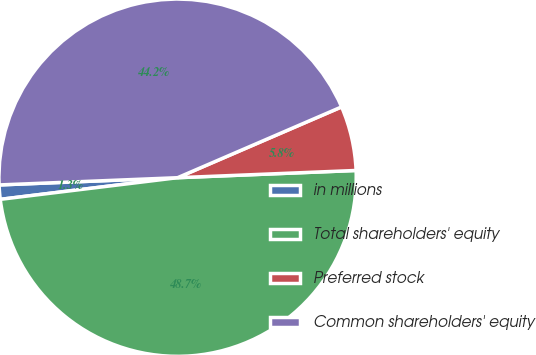Convert chart. <chart><loc_0><loc_0><loc_500><loc_500><pie_chart><fcel>in millions<fcel>Total shareholders' equity<fcel>Preferred stock<fcel>Common shareholders' equity<nl><fcel>1.29%<fcel>48.71%<fcel>5.84%<fcel>44.16%<nl></chart> 